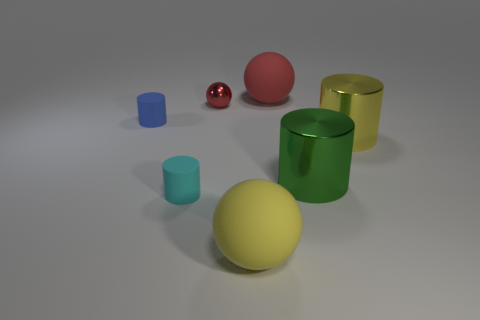Do the tiny thing that is in front of the blue thing and the yellow cylinder have the same material?
Your answer should be very brief. No. There is a large yellow thing behind the big yellow ball; are there any large yellow objects on the left side of it?
Make the answer very short. Yes. There is a green object that is the same shape as the yellow metal object; what is it made of?
Make the answer very short. Metal. Are there more tiny cyan things in front of the blue cylinder than tiny cyan objects behind the tiny metal object?
Provide a short and direct response. Yes. What is the shape of the tiny blue thing that is the same material as the large red object?
Your response must be concise. Cylinder. Are there more cylinders that are to the left of the big red matte sphere than metal cylinders?
Make the answer very short. No. What number of tiny cylinders have the same color as the tiny metallic ball?
Give a very brief answer. 0. What number of other objects are there of the same color as the small metallic sphere?
Your response must be concise. 1. Are there more big green metal things than big yellow things?
Provide a succinct answer. No. What is the material of the large red thing?
Your answer should be very brief. Rubber. 